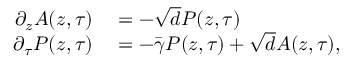Convert formula to latex. <formula><loc_0><loc_0><loc_500><loc_500>\begin{array} { r l } { \partial _ { z } A ( z , \tau ) } & = - \sqrt { d } P ( z , \tau ) } \\ { \partial _ { \tau } P ( z , \tau ) } & = - \bar { \gamma } P ( z , \tau ) + \sqrt { d } A ( z , \tau ) , } \end{array}</formula> 